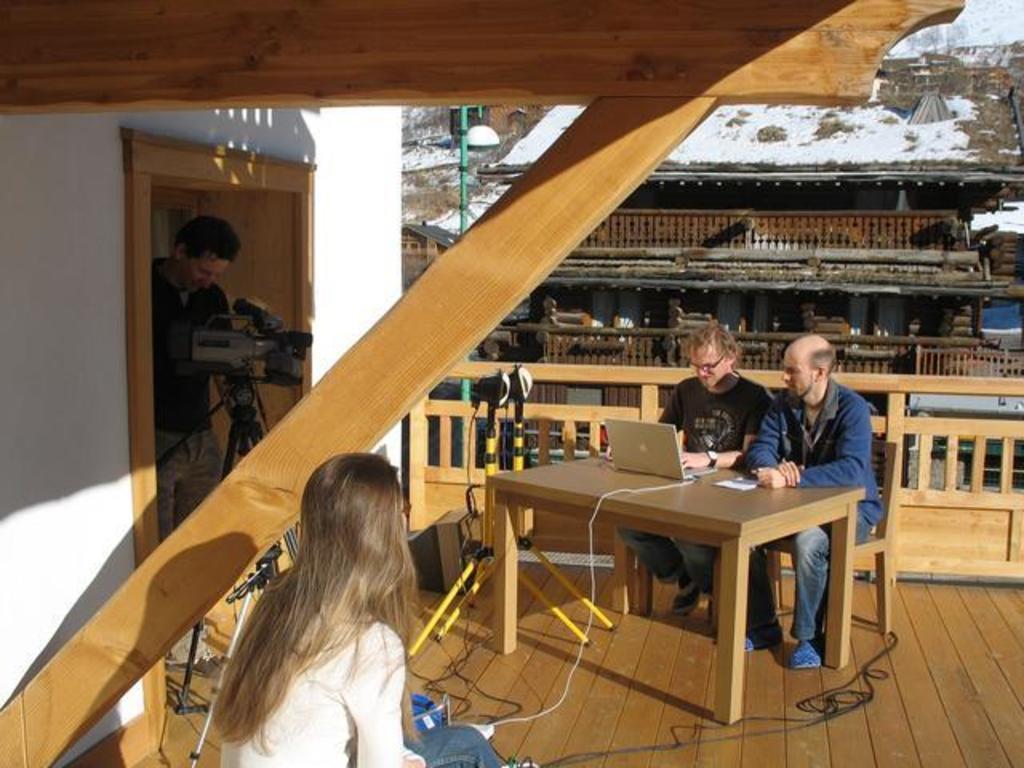Could you give a brief overview of what you see in this image? I can see in this image a group of people among them three people are sitting on a chair and one person is standing on the ground. On the table we have a laptop and other objects on it. I can also see a video camera, a wall and a fence. In the background we have a house. 